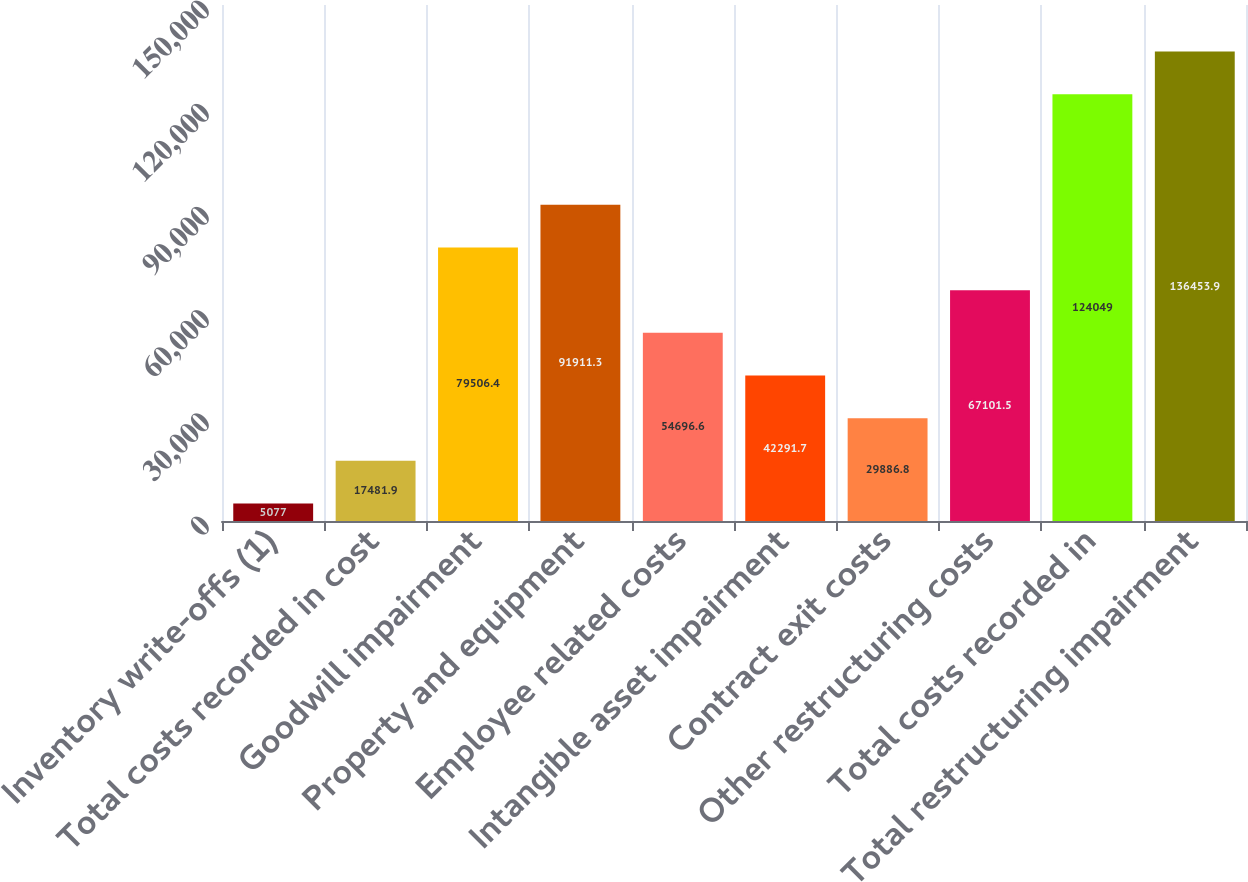<chart> <loc_0><loc_0><loc_500><loc_500><bar_chart><fcel>Inventory write-offs (1)<fcel>Total costs recorded in cost<fcel>Goodwill impairment<fcel>Property and equipment<fcel>Employee related costs<fcel>Intangible asset impairment<fcel>Contract exit costs<fcel>Other restructuring costs<fcel>Total costs recorded in<fcel>Total restructuring impairment<nl><fcel>5077<fcel>17481.9<fcel>79506.4<fcel>91911.3<fcel>54696.6<fcel>42291.7<fcel>29886.8<fcel>67101.5<fcel>124049<fcel>136454<nl></chart> 